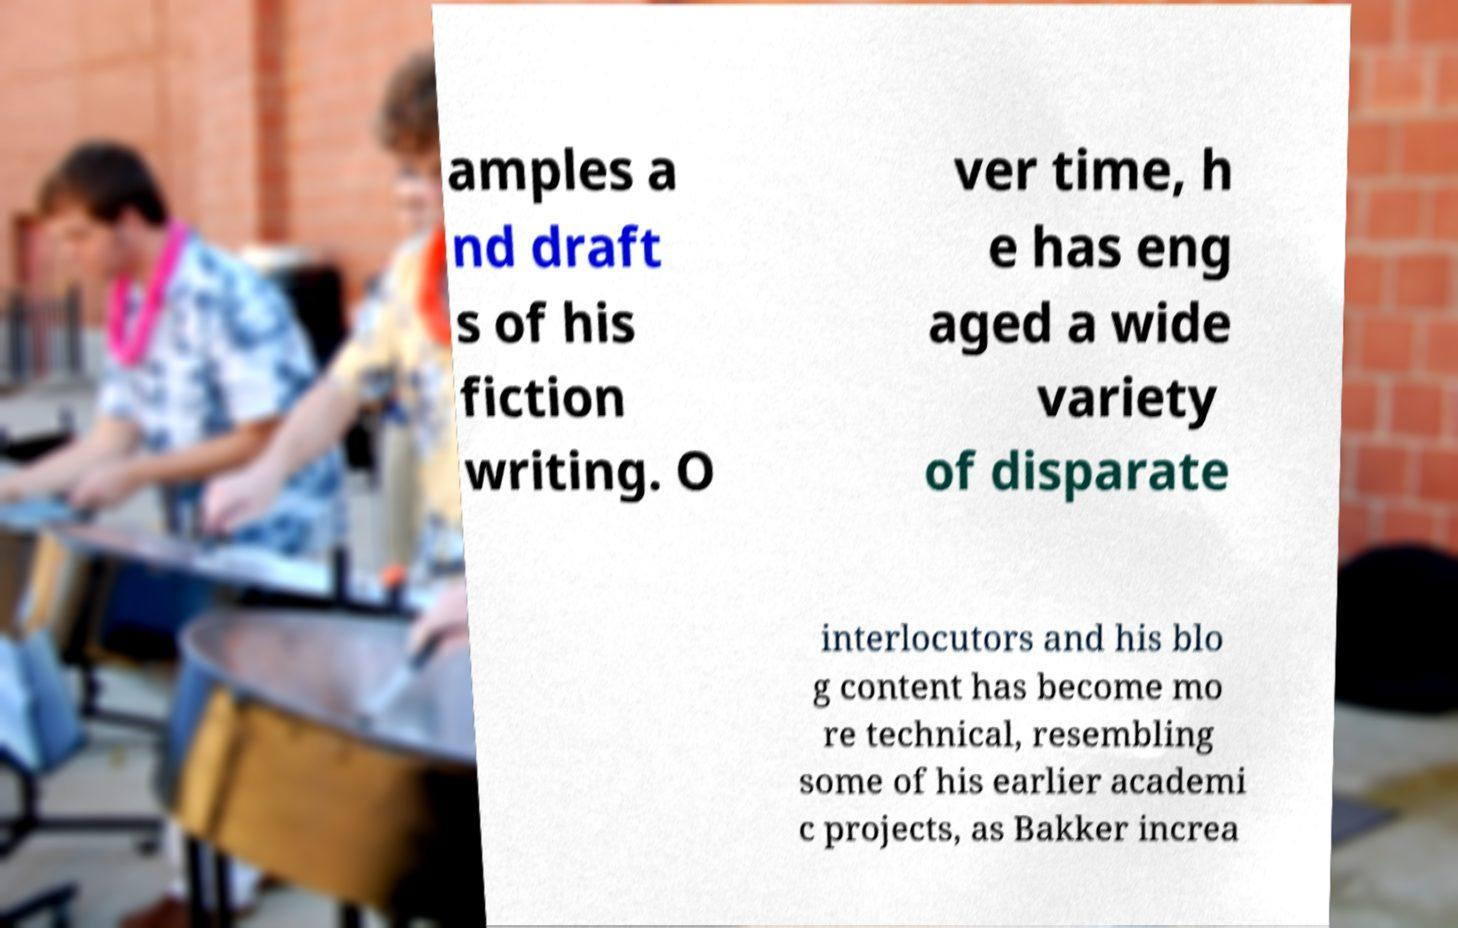Can you read and provide the text displayed in the image?This photo seems to have some interesting text. Can you extract and type it out for me? amples a nd draft s of his fiction writing. O ver time, h e has eng aged a wide variety of disparate interlocutors and his blo g content has become mo re technical, resembling some of his earlier academi c projects, as Bakker increa 